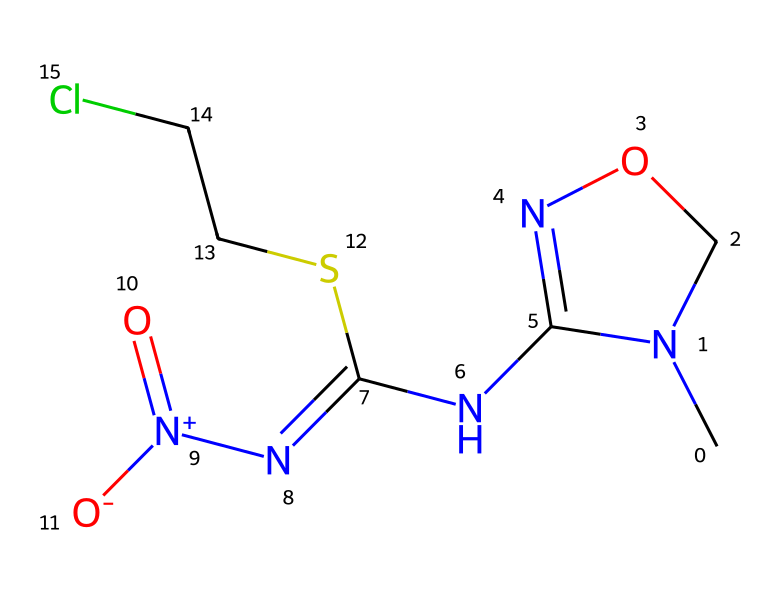How many nitrogen atoms are present in this chemical? In the provided SMILES representation, 'N' indicates the presence of nitrogen atoms. By scanning through the representation, we can count four 'N's present.
Answer: four What is the primary functional group in this chemical? The chemical structure contains a nitro group (indicated by 'N+')(=O)[O-]), which is characteristic of a nitro compound. The presence of multiple functional groups complicates the structure, but the nitro group predominates.
Answer: nitro What is the total number of carbon atoms in this chemical? To find the number of carbon atoms in the SMILES structure, we look for 'C' indications in the representation while ignoring those that are part of other elements. Counting all 'C's, we find a total of five carbon atoms.
Answer: five What is the significance of the chloro (Cl) substituent in this insecticide? The chloro group (represented by 'Cl') is a halogen, and chlorinated compounds often exhibit greater bioactivity and stability in pesticides, making them effective in pest control.
Answer: bioactivity What type of insecticide does this chemical represent? This chemical belongs to the neonicotinoid class, which is specifically designed to target the nervous system of insects, disrupting their normal function.
Answer: neonicotinoid How many sulfur atoms are present in this chemical? Upon examining the structure, we find one occurrence of 'S', indicating the presence of one sulfur atom in the molecular structure.
Answer: one What does the presence of the imino (C=N) bond in this chemical indicate? The imino bond introduces a means of resonance stabilization within the chemical structure, which can significantly affect the reactivity and properties of the insecticide, enhancing its effectiveness.
Answer: resonance stabilization 